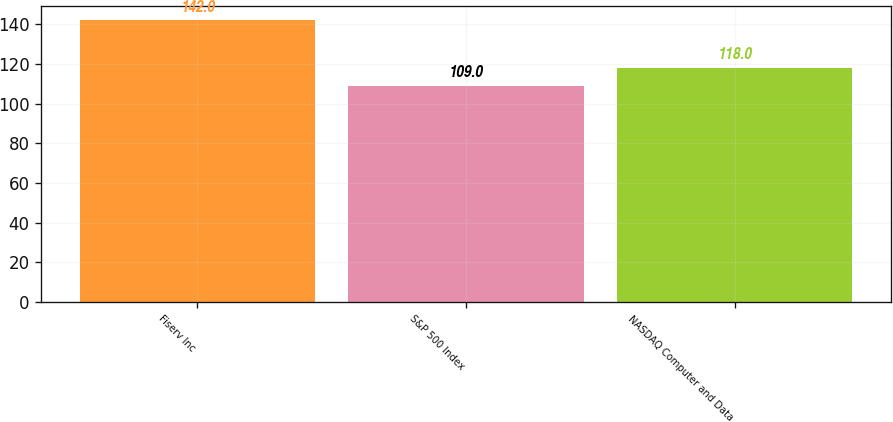<chart> <loc_0><loc_0><loc_500><loc_500><bar_chart><fcel>Fiserv Inc<fcel>S&P 500 Index<fcel>NASDAQ Computer and Data<nl><fcel>142<fcel>109<fcel>118<nl></chart> 